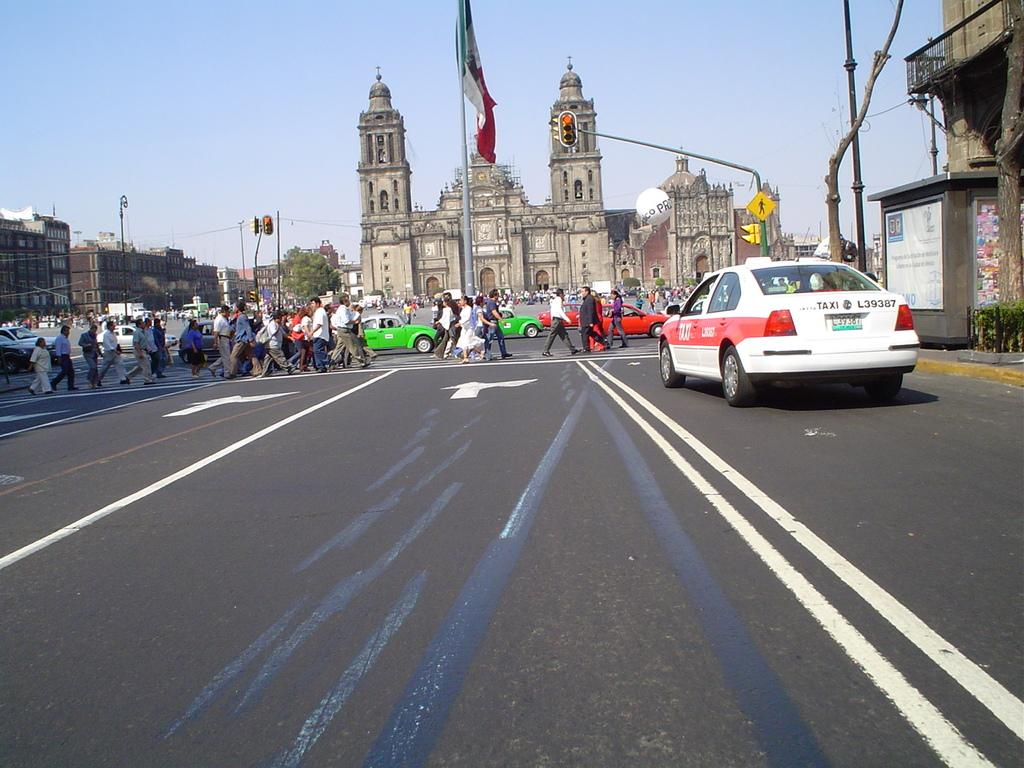Provide a one-sentence caption for the provided image. Taxi number L39387 waits at a busy crosswalk. 